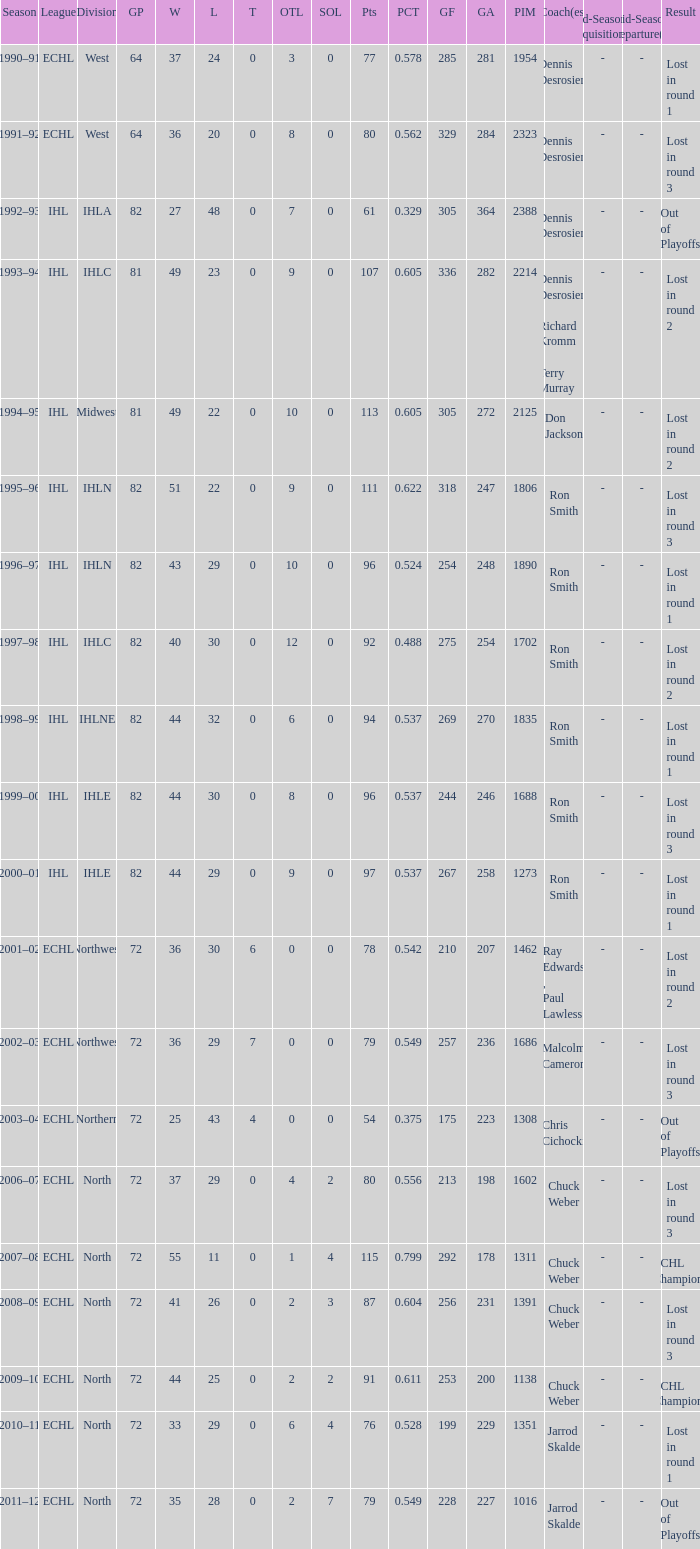I'm looking to parse the entire table for insights. Could you assist me with that? {'header': ['Season', 'League', 'Division', 'GP', 'W', 'L', 'T', 'OTL', 'SOL', 'Pts', 'PCT', 'GF', 'GA', 'PIM', 'Coach(es)', 'Mid-Season Acquisition(s)', 'Mid-Season Departure(s)', 'Result'], 'rows': [['1990–91', 'ECHL', 'West', '64', '37', '24', '0', '3', '0', '77', '0.578', '285', '281', '1954', 'Dennis Desrosiers', '-', '-', 'Lost in round 1'], ['1991–92', 'ECHL', 'West', '64', '36', '20', '0', '8', '0', '80', '0.562', '329', '284', '2323', 'Dennis Desrosiers', '-', '-', 'Lost in round 3'], ['1992–93', 'IHL', 'IHLA', '82', '27', '48', '0', '7', '0', '61', '0.329', '305', '364', '2388', 'Dennis Desrosiers', '-', '-', 'Out of Playoffs'], ['1993–94', 'IHL', 'IHLC', '81', '49', '23', '0', '9', '0', '107', '0.605', '336', '282', '2214', 'Dennis Desrosiers , Richard Kromm , Terry Murray', '-', '-', 'Lost in round 2'], ['1994–95', 'IHL', 'Midwest', '81', '49', '22', '0', '10', '0', '113', '0.605', '305', '272', '2125', 'Don Jackson', '-', '-', 'Lost in round 2'], ['1995–96', 'IHL', 'IHLN', '82', '51', '22', '0', '9', '0', '111', '0.622', '318', '247', '1806', 'Ron Smith', '-', '-', 'Lost in round 3'], ['1996–97', 'IHL', 'IHLN', '82', '43', '29', '0', '10', '0', '96', '0.524', '254', '248', '1890', 'Ron Smith', '-', '-', 'Lost in round 1'], ['1997–98', 'IHL', 'IHLC', '82', '40', '30', '0', '12', '0', '92', '0.488', '275', '254', '1702', 'Ron Smith', '-', '-', 'Lost in round 2'], ['1998–99', 'IHL', 'IHLNE', '82', '44', '32', '0', '6', '0', '94', '0.537', '269', '270', '1835', 'Ron Smith', '-', '-', 'Lost in round 1'], ['1999–00', 'IHL', 'IHLE', '82', '44', '30', '0', '8', '0', '96', '0.537', '244', '246', '1688', 'Ron Smith', '-', '-', 'Lost in round 3'], ['2000–01', 'IHL', 'IHLE', '82', '44', '29', '0', '9', '0', '97', '0.537', '267', '258', '1273', 'Ron Smith', '-', '-', 'Lost in round 1'], ['2001–02', 'ECHL', 'Northwest', '72', '36', '30', '6', '0', '0', '78', '0.542', '210', '207', '1462', 'Ray Edwards , Paul Lawless', '-', '-', 'Lost in round 2'], ['2002–03', 'ECHL', 'Northwest', '72', '36', '29', '7', '0', '0', '79', '0.549', '257', '236', '1686', 'Malcolm Cameron', '-', '-', 'Lost in round 3'], ['2003–04', 'ECHL', 'Northern', '72', '25', '43', '4', '0', '0', '54', '0.375', '175', '223', '1308', 'Chris Cichocki', '-', '-', 'Out of Playoffs'], ['2006–07', 'ECHL', 'North', '72', '37', '29', '0', '4', '2', '80', '0.556', '213', '198', '1602', 'Chuck Weber', '-', '-', 'Lost in round 3'], ['2007–08', 'ECHL', 'North', '72', '55', '11', '0', '1', '4', '115', '0.799', '292', '178', '1311', 'Chuck Weber', '-', '-', 'ECHL Champions'], ['2008–09', 'ECHL', 'North', '72', '41', '26', '0', '2', '3', '87', '0.604', '256', '231', '1391', 'Chuck Weber', '-', '-', 'Lost in round 3'], ['2009–10', 'ECHL', 'North', '72', '44', '25', '0', '2', '2', '91', '0.611', '253', '200', '1138', 'Chuck Weber', '-', '-', 'ECHL Champions'], ['2010–11', 'ECHL', 'North', '72', '33', '29', '0', '6', '4', '76', '0.528', '199', '229', '1351', 'Jarrod Skalde', '-', '-', 'Lost in round 1'], ['2011–12', 'ECHL', 'North', '72', '35', '28', '0', '2', '7', '79', '0.549', '228', '227', '1016', 'Jarrod Skalde', '-', '-', 'Out of Playoffs']]} What was the season where the team reached a GP of 244? 1999–00. 